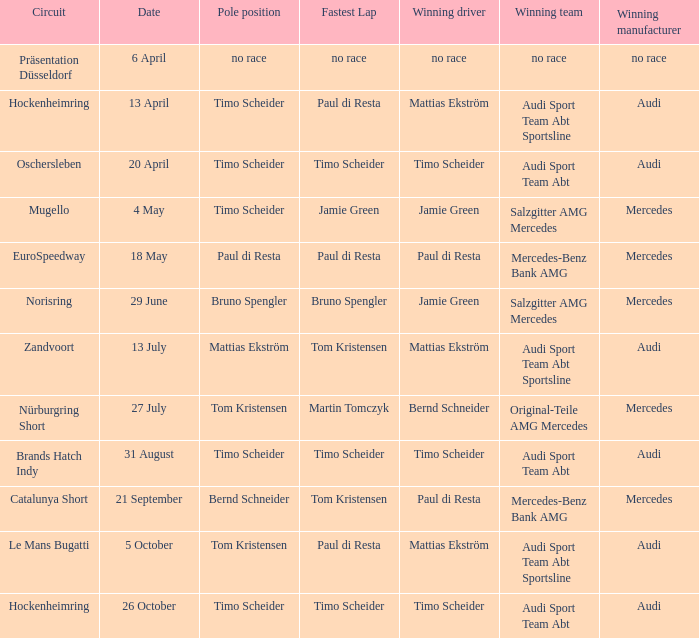What is the fastest lap of the Oschersleben circuit with Audi Sport Team ABT as the winning team? Timo Scheider. 